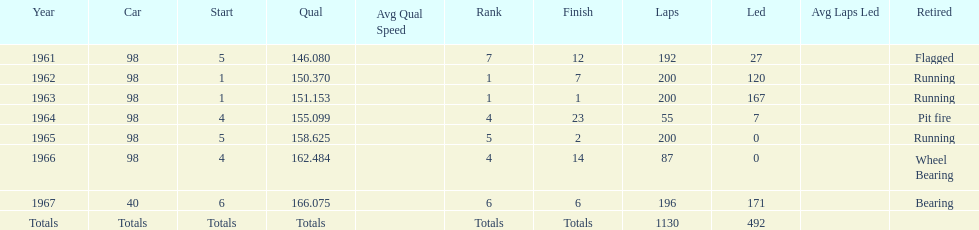What car achieved the highest qual? 40. 